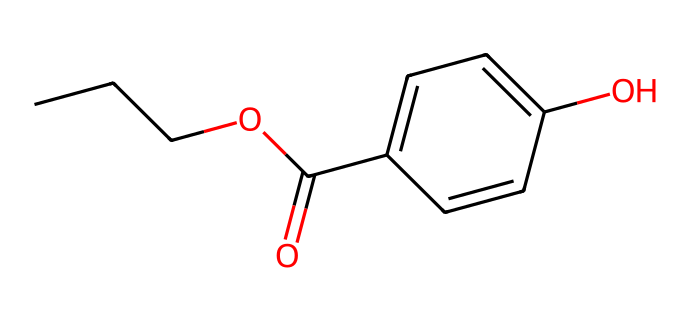What is the main functional group in propylparaben? The SMILES representation indicates the presence of an ester functional group, characterized by the connection of a carbonyl group (C=O) to an ether (CO) connected to an alkyl chain. This is shown in the segment "OC(=O)" in the structure.
Answer: ester How many carbon atoms are present in propylparaben? Counting the carbon atoms in the chemical structure derived from the SMILES, we see a total of 10 carbon atoms, as indicated by the sequence of 'C' characters and the alkyl groups around the cyclic structure.
Answer: 10 What type of compound is propylparaben classified as? Propylparaben is classified as a preservative based on its function and structure, which includes aromatic and aliphatic components, commonly used in cosmetics to prevent microbial growth.
Answer: preservative How many hydroxyl groups are present in propylparaben? The number of hydroxyl (–OH) groups can be identified from the structure where we see a 'O' associated with a carbon, specifically in the notation "C1=CC...O," indicating there are two –OH groups in propylparaben.
Answer: 2 What is the total number of hydrogen atoms in propylparaben? To find the hydrogen count, we analyze the structure. Each carbon typically has enough hydrogens to satisfy its tetravalency, which will total to 12 in propylparaben after accounting for the hydrogens lost during bond formations with other atoms, leading to a hydrogen total of 12.
Answer: 12 